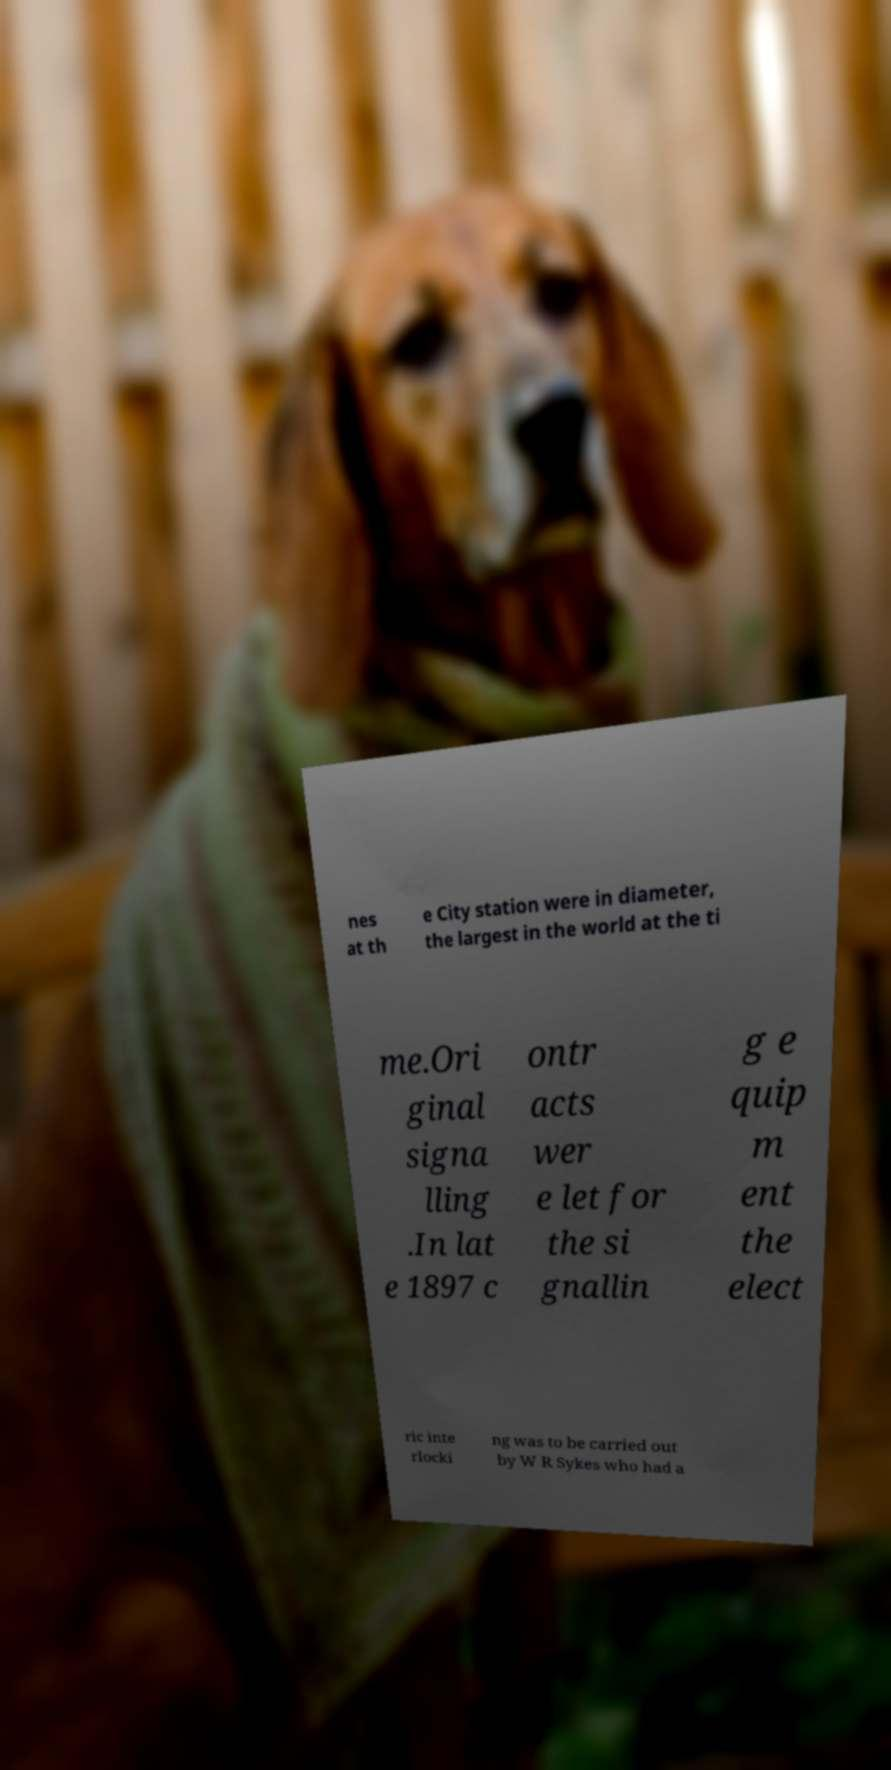Can you read and provide the text displayed in the image?This photo seems to have some interesting text. Can you extract and type it out for me? nes at th e City station were in diameter, the largest in the world at the ti me.Ori ginal signa lling .In lat e 1897 c ontr acts wer e let for the si gnallin g e quip m ent the elect ric inte rlocki ng was to be carried out by W R Sykes who had a 